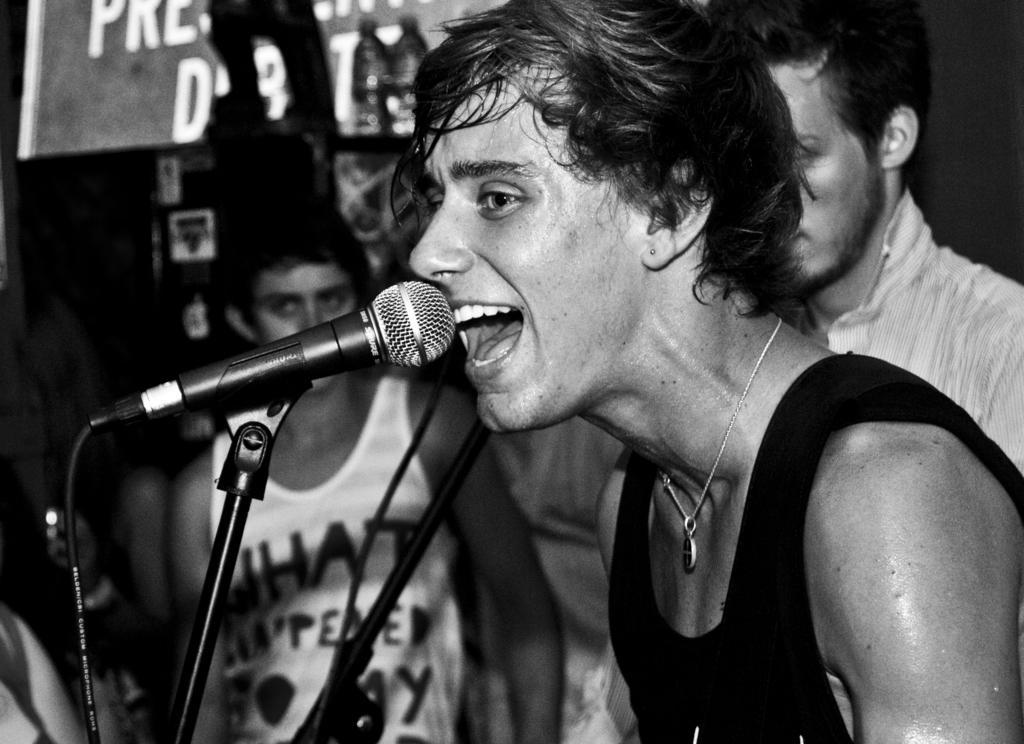Describe this image in one or two sentences. In this image there a boy wearing black sleeveless singing in the black microphone. Behind there are two boy looking into the camera. 